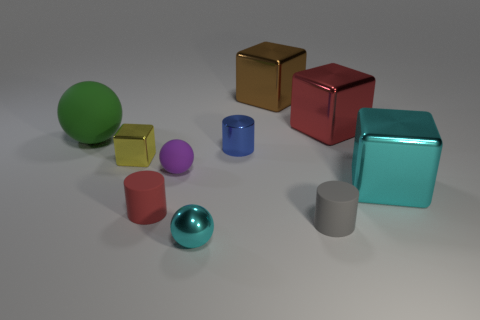Subtract all metal cylinders. How many cylinders are left? 2 Subtract 2 balls. How many balls are left? 1 Subtract all red cylinders. How many cylinders are left? 2 Add 9 tiny purple rubber spheres. How many tiny purple rubber spheres are left? 10 Add 9 small cyan shiny cylinders. How many small cyan shiny cylinders exist? 9 Subtract 0 gray blocks. How many objects are left? 10 Subtract all balls. How many objects are left? 7 Subtract all purple cylinders. Subtract all green spheres. How many cylinders are left? 3 Subtract all big brown shiny things. Subtract all matte balls. How many objects are left? 7 